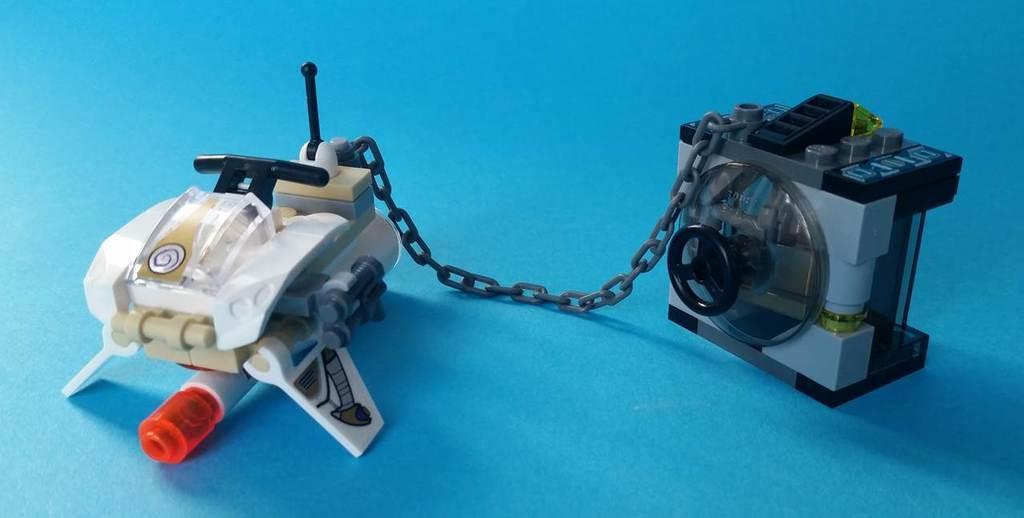Please provide a concise description of this image. In this image I see 2 toys which are of white, cream, red, grey and black in color and they're on the blue color surface. 